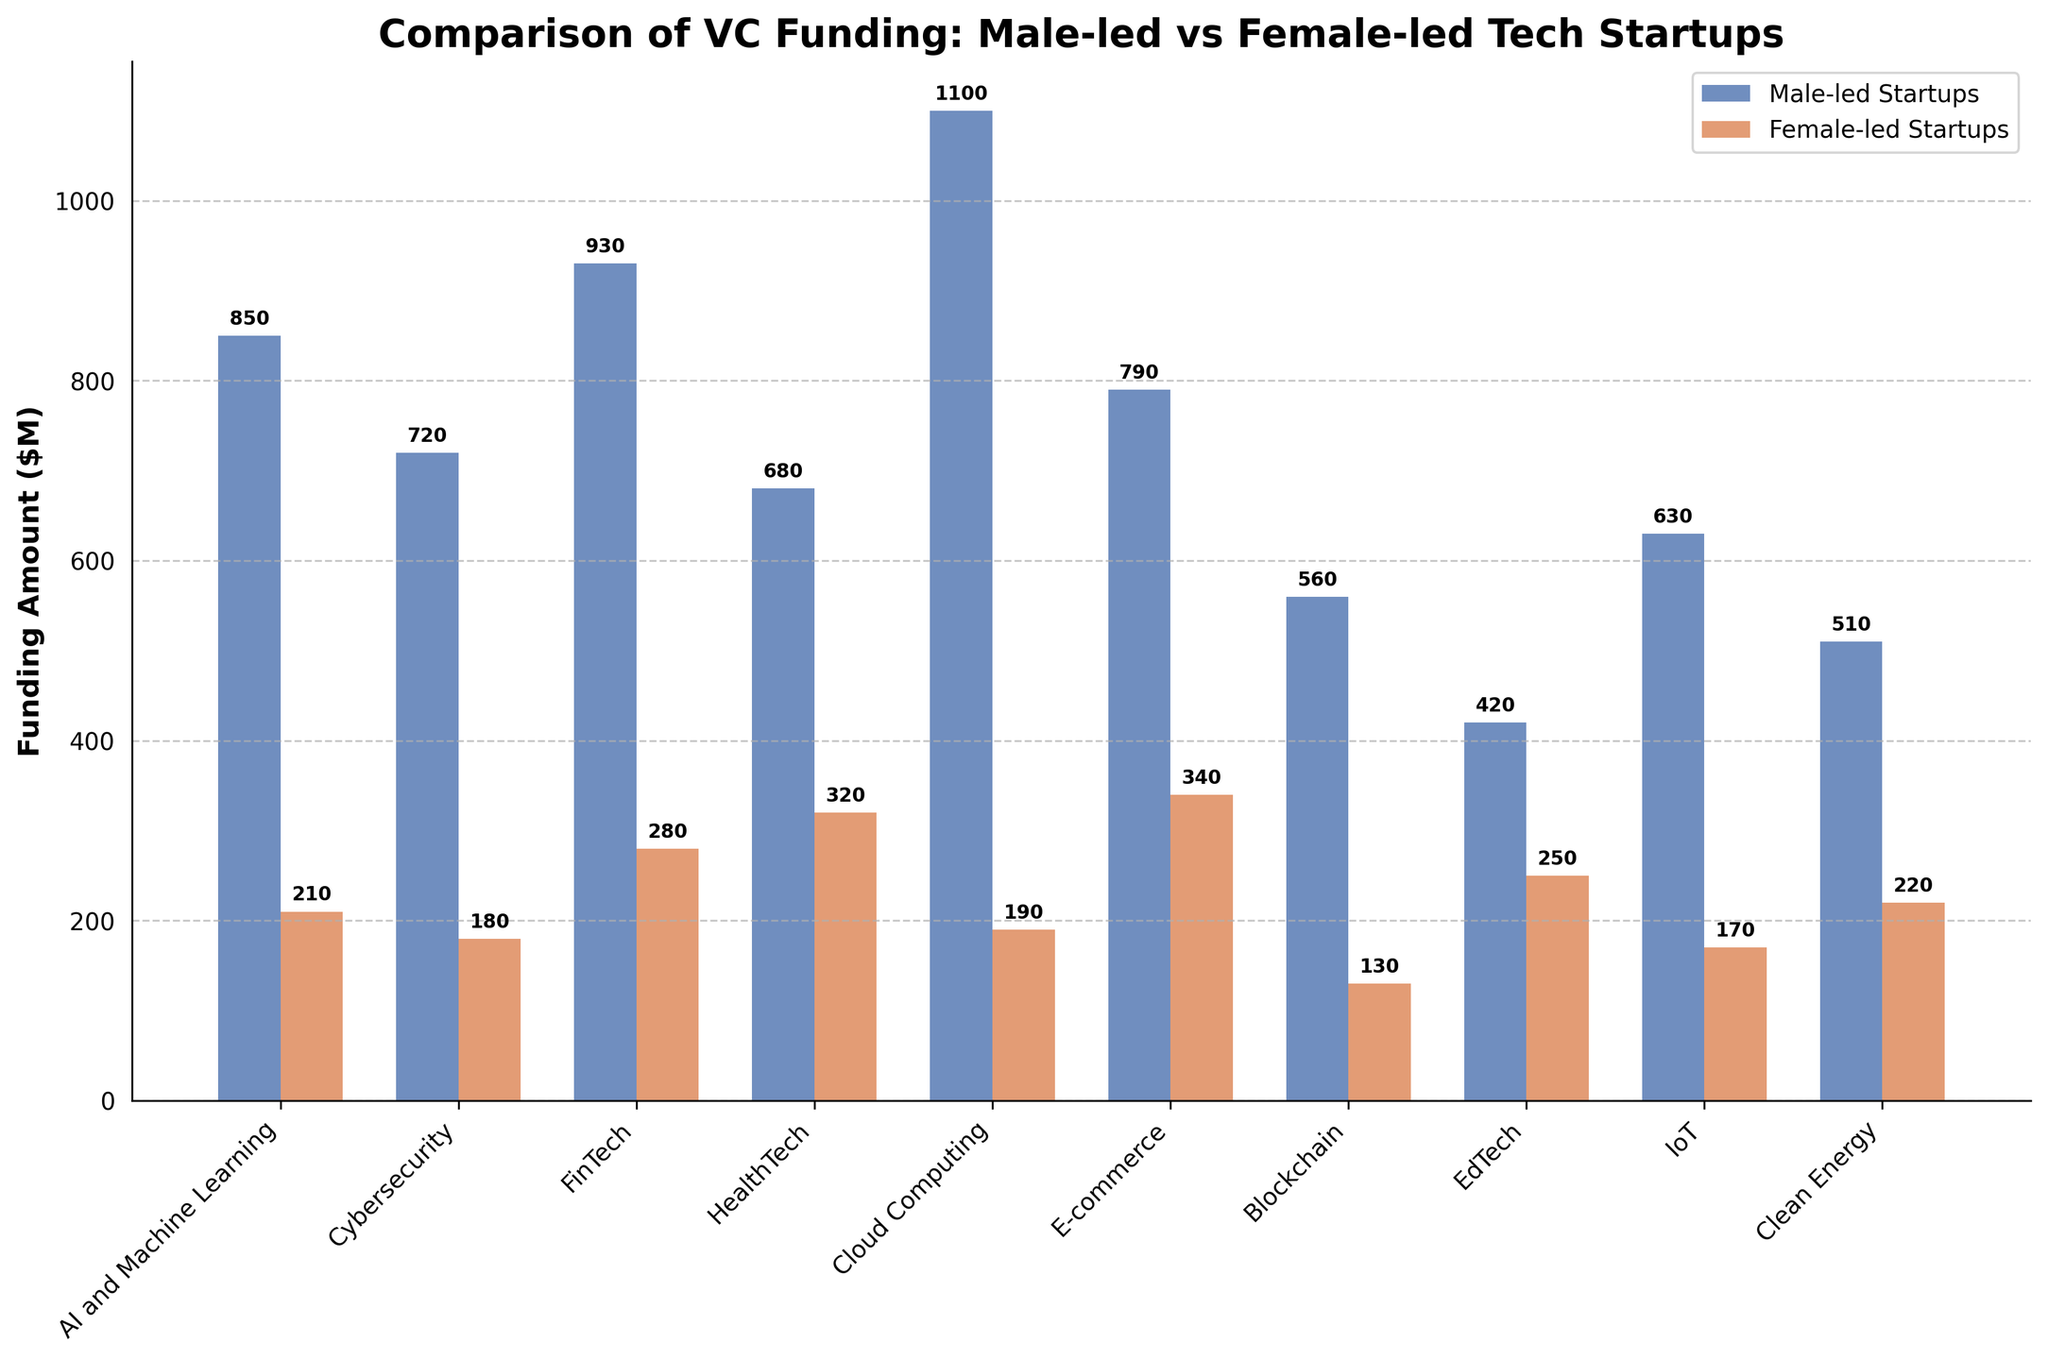What sector received the highest VC funding for male-led startups? By observing the height of the bars representing male-led startups, the Cloud Computing sector has the tallest bar, indicating it received the highest VC funding among male-led startups.
Answer: Cloud Computing How much more funding did male-led startups receive in the AI and Machine Learning sector compared to female-led startups? The male-led startups in AI and Machine Learning received $850M, and the female-led startups received $210M. The difference is $850M - $210M.
Answer: $640M Which sector has the smallest funding difference between male-led and female-led startups? By comparing the difference between the heights of the bars for each sector, the HealthTech sector has the smallest difference ($680M for male-led and $320M for female-led, difference of $360M).
Answer: HealthTech What is the total funding amount for female-led startups across all sectors? Summing up the funding amounts for female-led startups: $210M + $180M + $280M + $320M + $190M + $340M + $130M + $250M + $170M + $220M.
Answer: $2290M In terms of funding received, which has a bigger discrepancy: AI and Machine Learning or Cybersecurity? Calculate the differences: AI and Machine Learning: $850M - $210M = $640M. Cybersecurity: $720M - $180M = $540M. Comparing the values, AI and Machine Learning has the bigger discrepancy.
Answer: AI and Machine Learning Which has the highest funding among female-led startups: EdTech or Clean Energy? By comparing the heights of the bars for female-led startups, EdTech has a higher bar at $250M compared to $220M for Clean Energy.
Answer: EdTech What is the average funding amount for male-led startups? Sum the funding amounts for male-led startups and divide by the number of sectors: ($850M + $720M + $930M + $680M + $1100M + $790M + $560M + $420M + $630M + $510M) / 10.
Answer: $719M Which sectors have female-led startups receiving more than $300M in funding? By observing the bars, the female-led startups in the sectors E-commerce ($340M) and HealthTech ($320M) received more than $300M each.
Answer: E-commerce, HealthTech Which sector has the second highest funding for female-led startups? By comparing the heights of the bars for female-led startups, the E-commerce sector has the highest funding, followed by HealthTech with the second highest funding at $320M.
Answer: HealthTech 